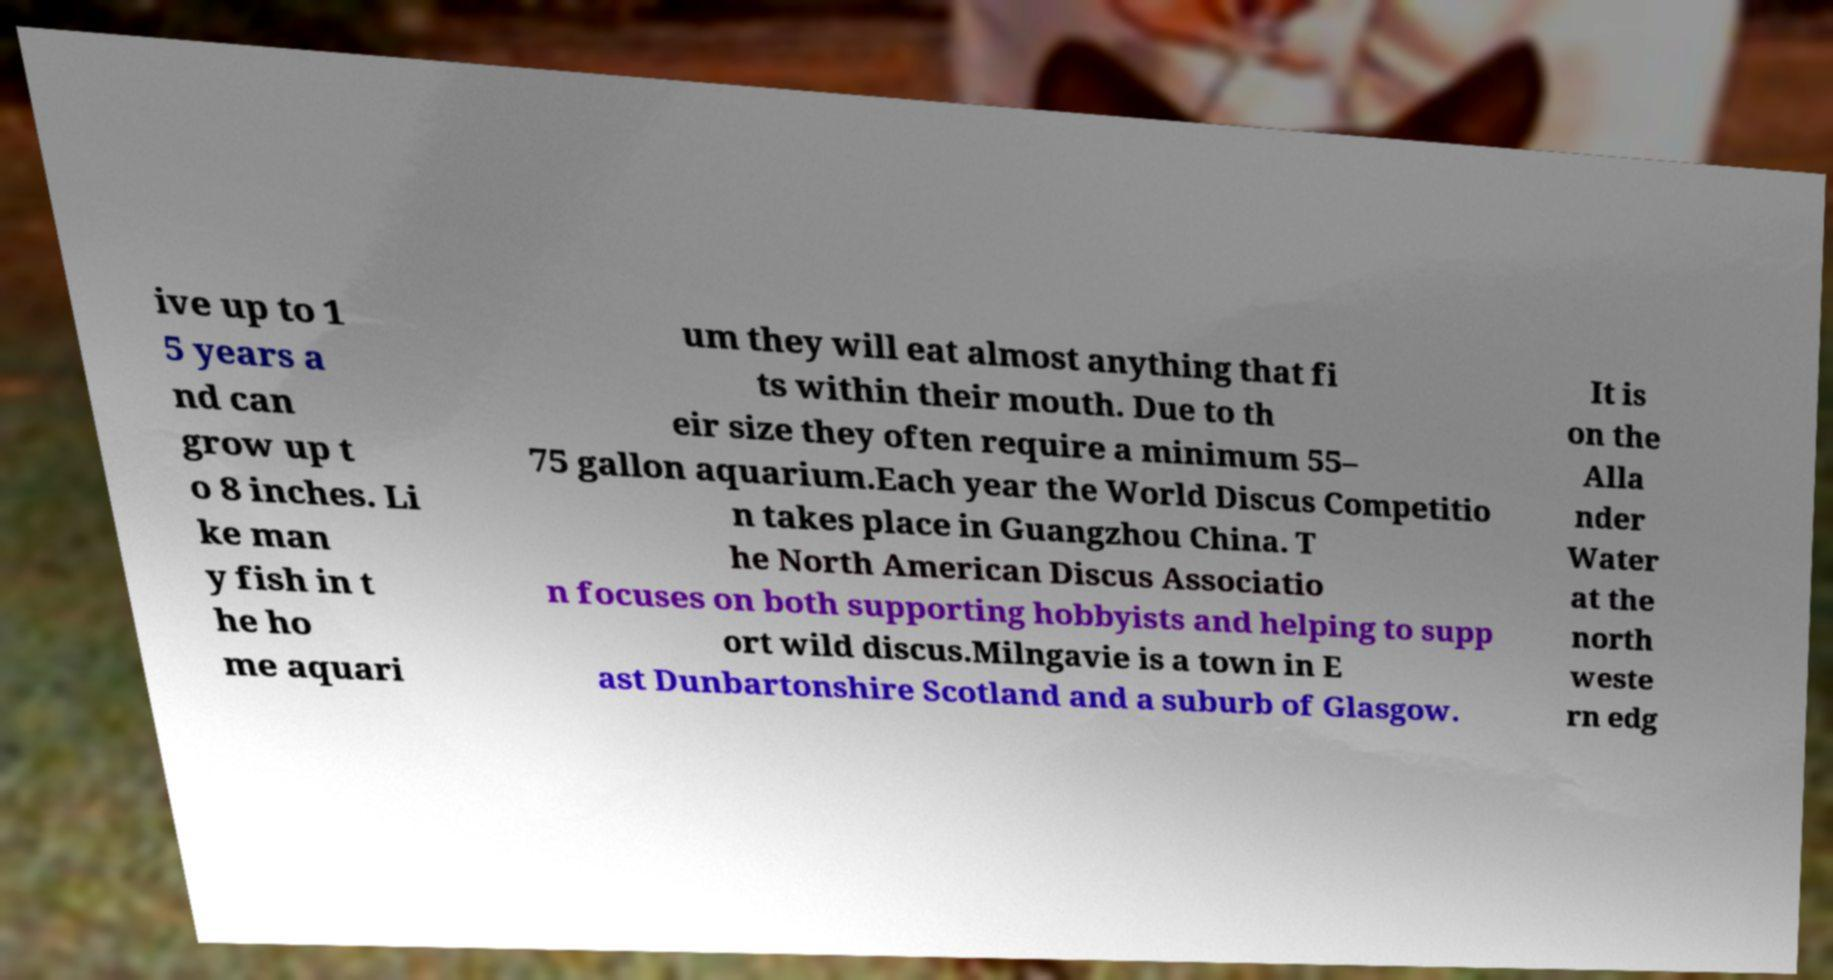Please read and relay the text visible in this image. What does it say? ive up to 1 5 years a nd can grow up t o 8 inches. Li ke man y fish in t he ho me aquari um they will eat almost anything that fi ts within their mouth. Due to th eir size they often require a minimum 55– 75 gallon aquarium.Each year the World Discus Competitio n takes place in Guangzhou China. T he North American Discus Associatio n focuses on both supporting hobbyists and helping to supp ort wild discus.Milngavie is a town in E ast Dunbartonshire Scotland and a suburb of Glasgow. It is on the Alla nder Water at the north weste rn edg 